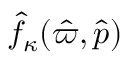<formula> <loc_0><loc_0><loc_500><loc_500>\hat { f } _ { \kappa } ( \hat { \varpi } , \hat { p } )</formula> 